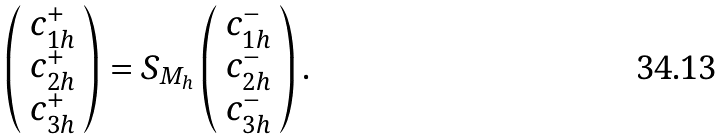Convert formula to latex. <formula><loc_0><loc_0><loc_500><loc_500>\left ( \begin{array} { c } c _ { 1 h } ^ { + } \\ c _ { 2 h } ^ { + } \\ c _ { 3 h } ^ { + } \end{array} \right ) = S _ { M _ { h } } \left ( \begin{array} { c } c _ { 1 h } ^ { - } \\ c _ { 2 h } ^ { - } \\ c _ { 3 h } ^ { - } \end{array} \right ) .</formula> 